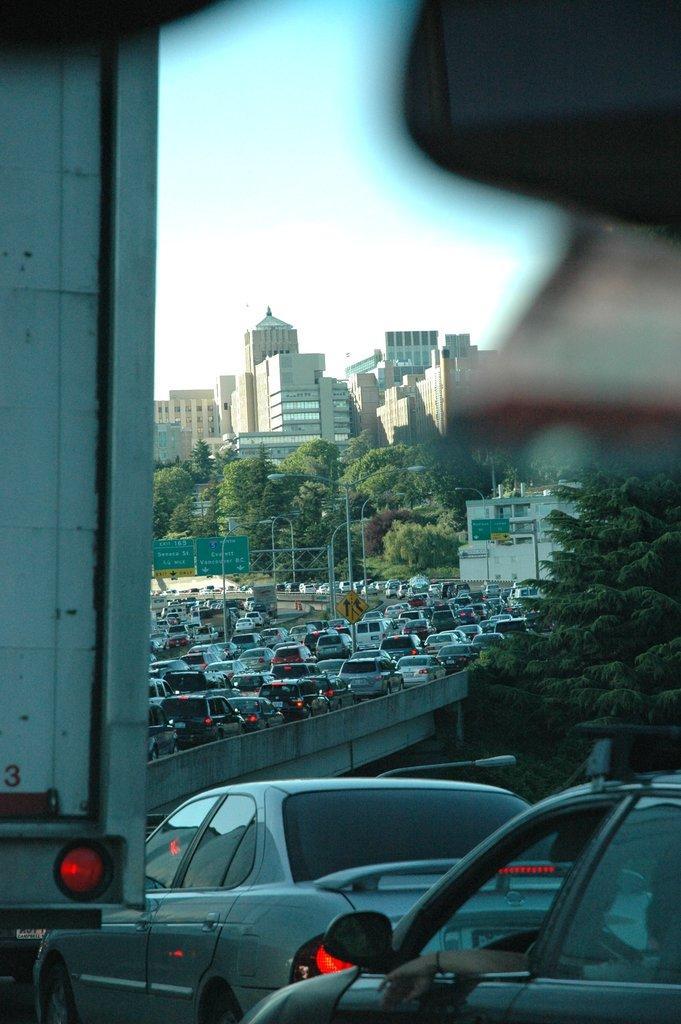Could you give a brief overview of what you see in this image? In this picture I can see vehicles on the fly over, there are boards, poles, lights, trees, buildings, and in the background there is sky. 